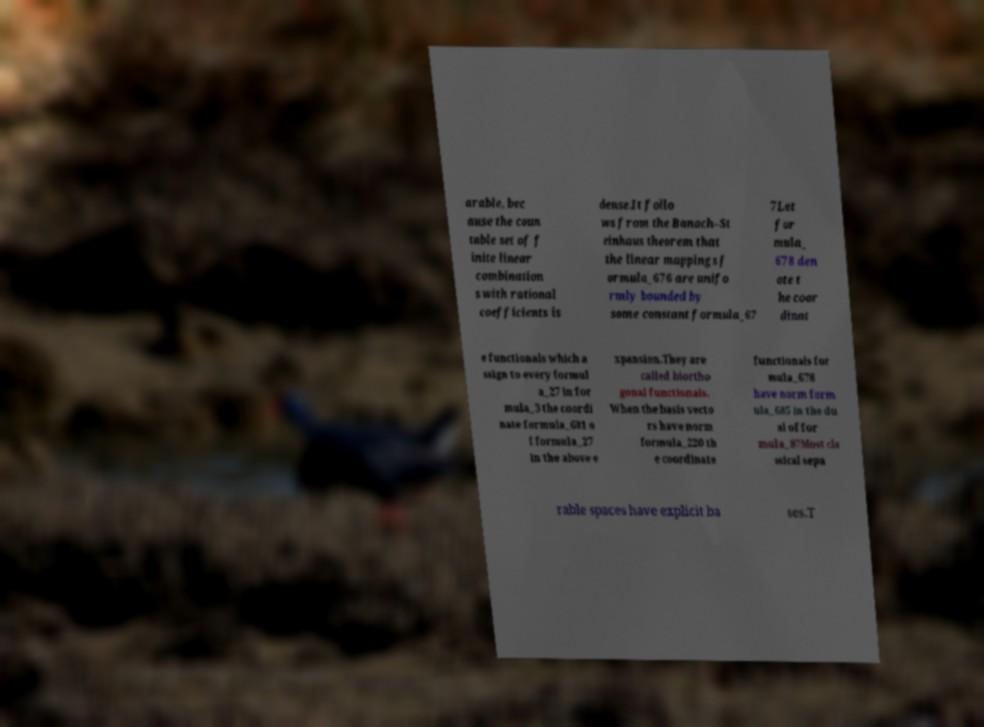Could you assist in decoding the text presented in this image and type it out clearly? arable, bec ause the coun table set of f inite linear combination s with rational coefficients is dense.It follo ws from the Banach–St einhaus theorem that the linear mappings f ormula_676 are unifo rmly bounded by some constant formula_67 7Let for mula_ 678 den ote t he coor dinat e functionals which a ssign to every formul a_27 in for mula_3 the coordi nate formula_681 o f formula_27 in the above e xpansion.They are called biortho gonal functionals. When the basis vecto rs have norm formula_220 th e coordinate functionals for mula_678 have norm form ula_685 in the du al of for mula_87Most cla ssical sepa rable spaces have explicit ba ses.T 